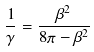Convert formula to latex. <formula><loc_0><loc_0><loc_500><loc_500>\frac { 1 } { \gamma } = \frac { \beta ^ { 2 } } { 8 \pi - \beta ^ { 2 } }</formula> 